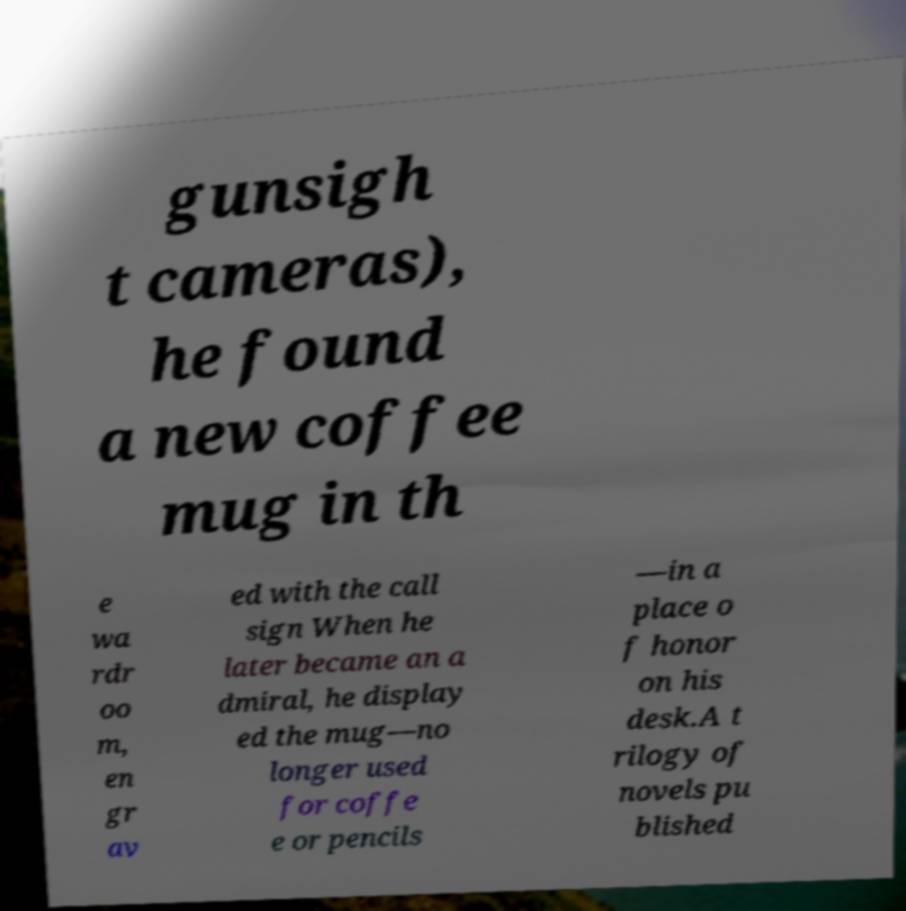Could you assist in decoding the text presented in this image and type it out clearly? gunsigh t cameras), he found a new coffee mug in th e wa rdr oo m, en gr av ed with the call sign When he later became an a dmiral, he display ed the mug—no longer used for coffe e or pencils —in a place o f honor on his desk.A t rilogy of novels pu blished 